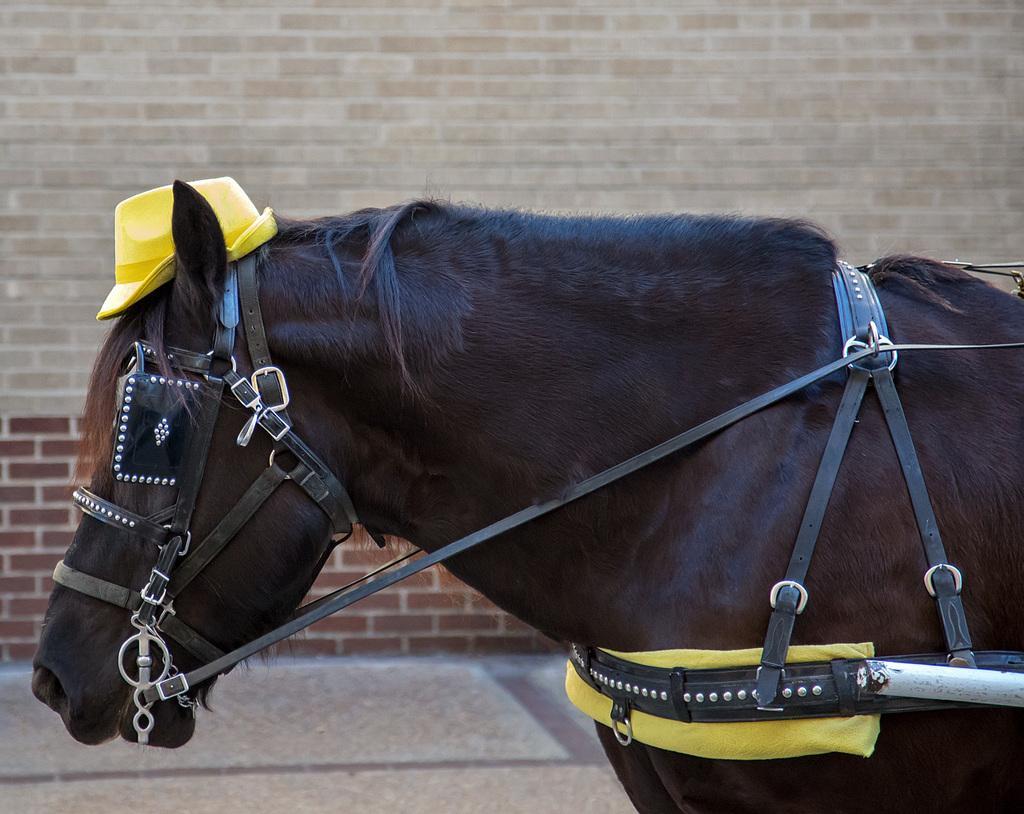In one or two sentences, can you explain what this image depicts? In this image I can see the horse which is in black and brown color. I can see some belts to the horse. In the background I can see the brick wall. 